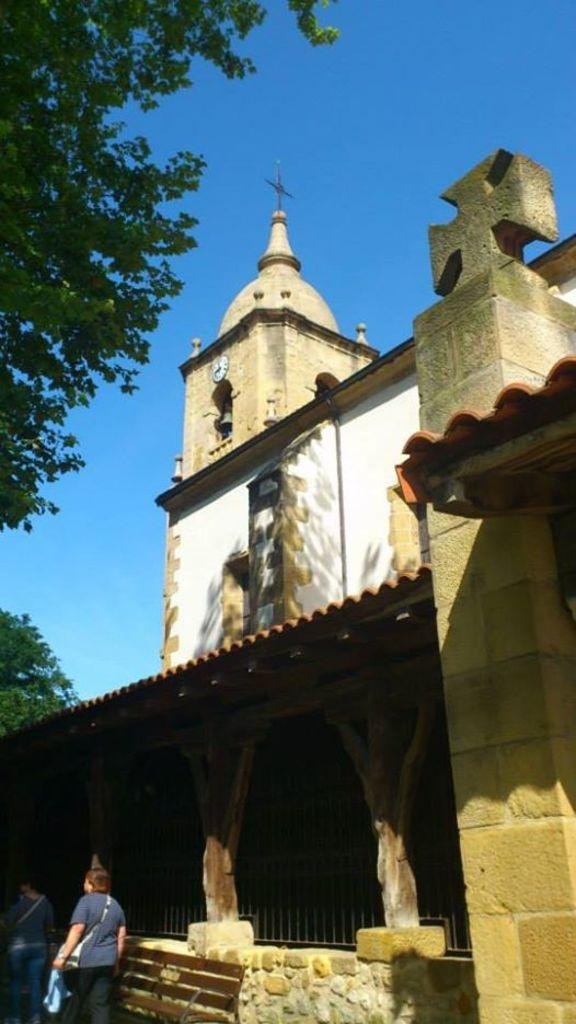What type of structure is in the image? There is a building in the image. What time-telling device is present in the image? There is a clock in the image. What type of barrier is visible in the image? Iron grills are present in the image. What type of seating is available in the image? There is a bench in the image. What are the people in the image doing? There are persons standing on the ground in the image. What type of vegetation is visible in the image? Trees are visible in the image. What part of the natural environment is visible in the image? The sky is visible in the image. What type of produce is being harvested by the persons in the image? There is no produce or harvesting activity depicted in the image. What type of game are the persons playing in the image? There is no game or play activity depicted in the image. 